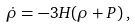Convert formula to latex. <formula><loc_0><loc_0><loc_500><loc_500>\dot { \rho } = - 3 H ( \rho + P ) \, ,</formula> 